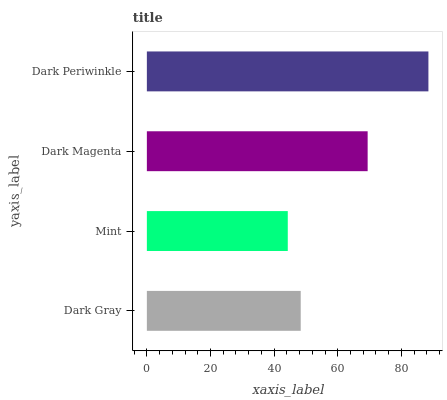Is Mint the minimum?
Answer yes or no. Yes. Is Dark Periwinkle the maximum?
Answer yes or no. Yes. Is Dark Magenta the minimum?
Answer yes or no. No. Is Dark Magenta the maximum?
Answer yes or no. No. Is Dark Magenta greater than Mint?
Answer yes or no. Yes. Is Mint less than Dark Magenta?
Answer yes or no. Yes. Is Mint greater than Dark Magenta?
Answer yes or no. No. Is Dark Magenta less than Mint?
Answer yes or no. No. Is Dark Magenta the high median?
Answer yes or no. Yes. Is Dark Gray the low median?
Answer yes or no. Yes. Is Dark Gray the high median?
Answer yes or no. No. Is Dark Magenta the low median?
Answer yes or no. No. 